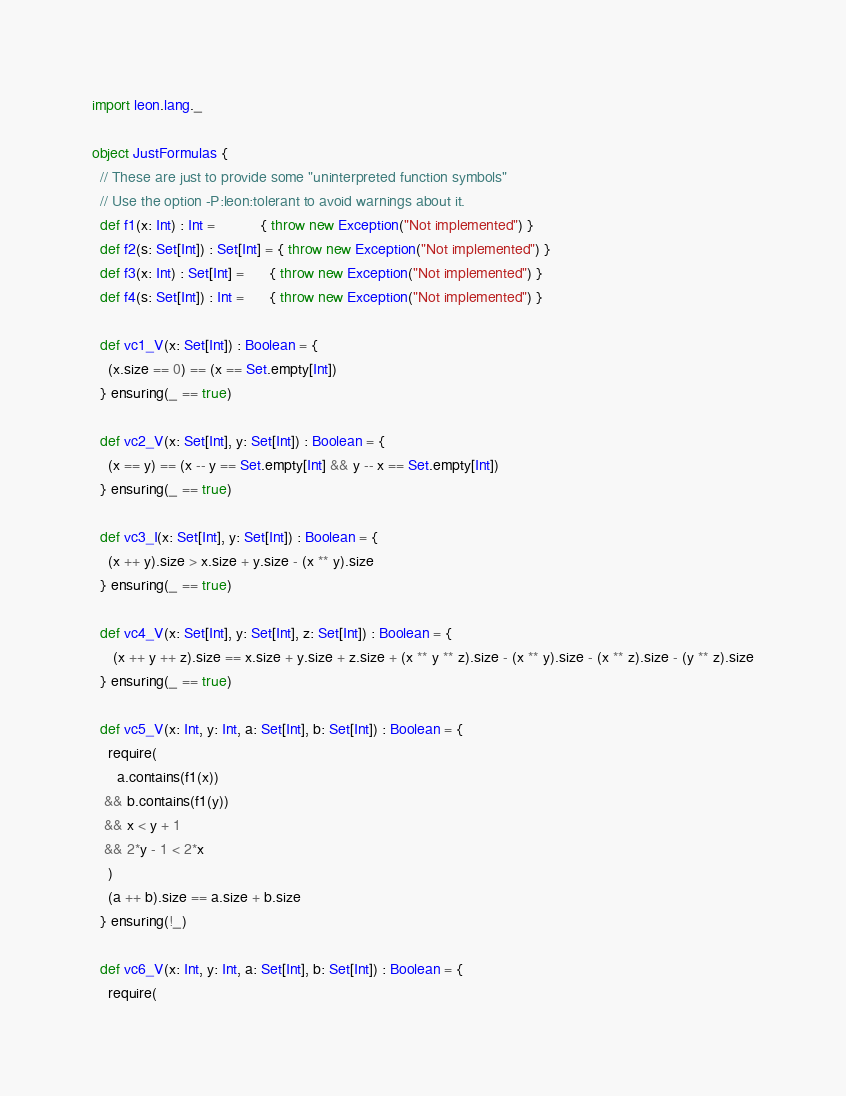<code> <loc_0><loc_0><loc_500><loc_500><_Scala_>import leon.lang._

object JustFormulas {
  // These are just to provide some "uninterpreted function symbols"
  // Use the option -P:leon:tolerant to avoid warnings about it.
  def f1(x: Int) : Int =           { throw new Exception("Not implemented") }
  def f2(s: Set[Int]) : Set[Int] = { throw new Exception("Not implemented") }
  def f3(x: Int) : Set[Int] =      { throw new Exception("Not implemented") }
  def f4(s: Set[Int]) : Int =      { throw new Exception("Not implemented") }

  def vc1_V(x: Set[Int]) : Boolean = {
    (x.size == 0) == (x == Set.empty[Int])
  } ensuring(_ == true)

  def vc2_V(x: Set[Int], y: Set[Int]) : Boolean = {
    (x == y) == (x -- y == Set.empty[Int] && y -- x == Set.empty[Int])
  } ensuring(_ == true)

  def vc3_I(x: Set[Int], y: Set[Int]) : Boolean = {
    (x ++ y).size > x.size + y.size - (x ** y).size
  } ensuring(_ == true)

  def vc4_V(x: Set[Int], y: Set[Int], z: Set[Int]) : Boolean = {
     (x ++ y ++ z).size == x.size + y.size + z.size + (x ** y ** z).size - (x ** y).size - (x ** z).size - (y ** z).size
  } ensuring(_ == true)

  def vc5_V(x: Int, y: Int, a: Set[Int], b: Set[Int]) : Boolean = {
    require(
      a.contains(f1(x))
   && b.contains(f1(y))
   && x < y + 1
   && 2*y - 1 < 2*x
    )
    (a ++ b).size == a.size + b.size
  } ensuring(!_)

  def vc6_V(x: Int, y: Int, a: Set[Int], b: Set[Int]) : Boolean = {
    require(</code> 